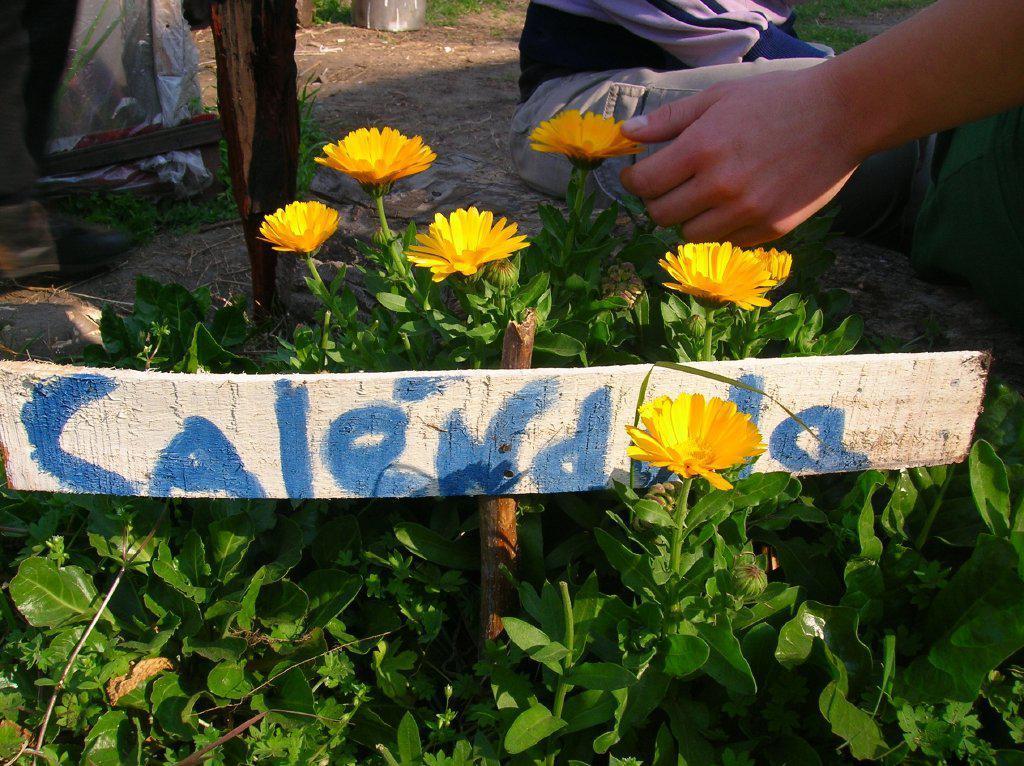In one or two sentences, can you explain what this image depicts? In this picture we can see a person's hand, wooden board, plants with flowers and in the background we can see some objects on the ground. 